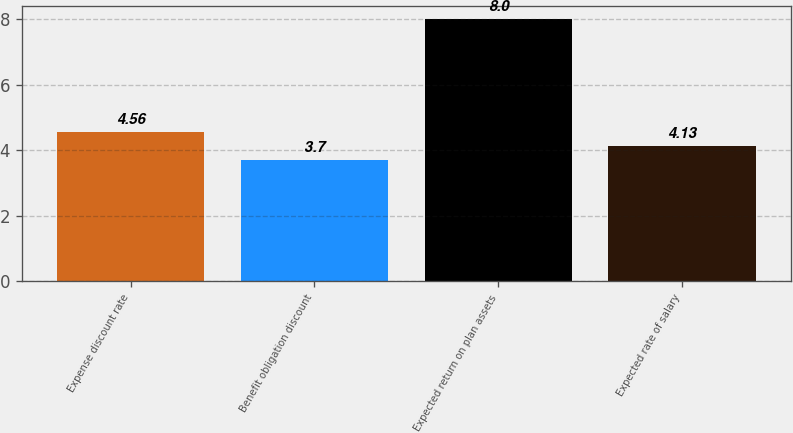<chart> <loc_0><loc_0><loc_500><loc_500><bar_chart><fcel>Expense discount rate<fcel>Benefit obligation discount<fcel>Expected return on plan assets<fcel>Expected rate of salary<nl><fcel>4.56<fcel>3.7<fcel>8<fcel>4.13<nl></chart> 